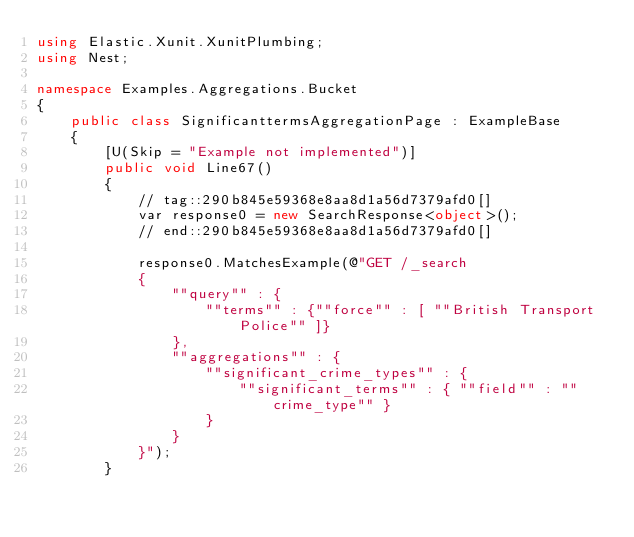Convert code to text. <code><loc_0><loc_0><loc_500><loc_500><_C#_>using Elastic.Xunit.XunitPlumbing;
using Nest;

namespace Examples.Aggregations.Bucket
{
	public class SignificanttermsAggregationPage : ExampleBase
	{
		[U(Skip = "Example not implemented")]
		public void Line67()
		{
			// tag::290b845e59368e8aa8d1a56d7379afd0[]
			var response0 = new SearchResponse<object>();
			// end::290b845e59368e8aa8d1a56d7379afd0[]

			response0.MatchesExample(@"GET /_search
			{
			    ""query"" : {
			        ""terms"" : {""force"" : [ ""British Transport Police"" ]}
			    },
			    ""aggregations"" : {
			        ""significant_crime_types"" : {
			            ""significant_terms"" : { ""field"" : ""crime_type"" }
			        }
			    }
			}");
		}
</code> 